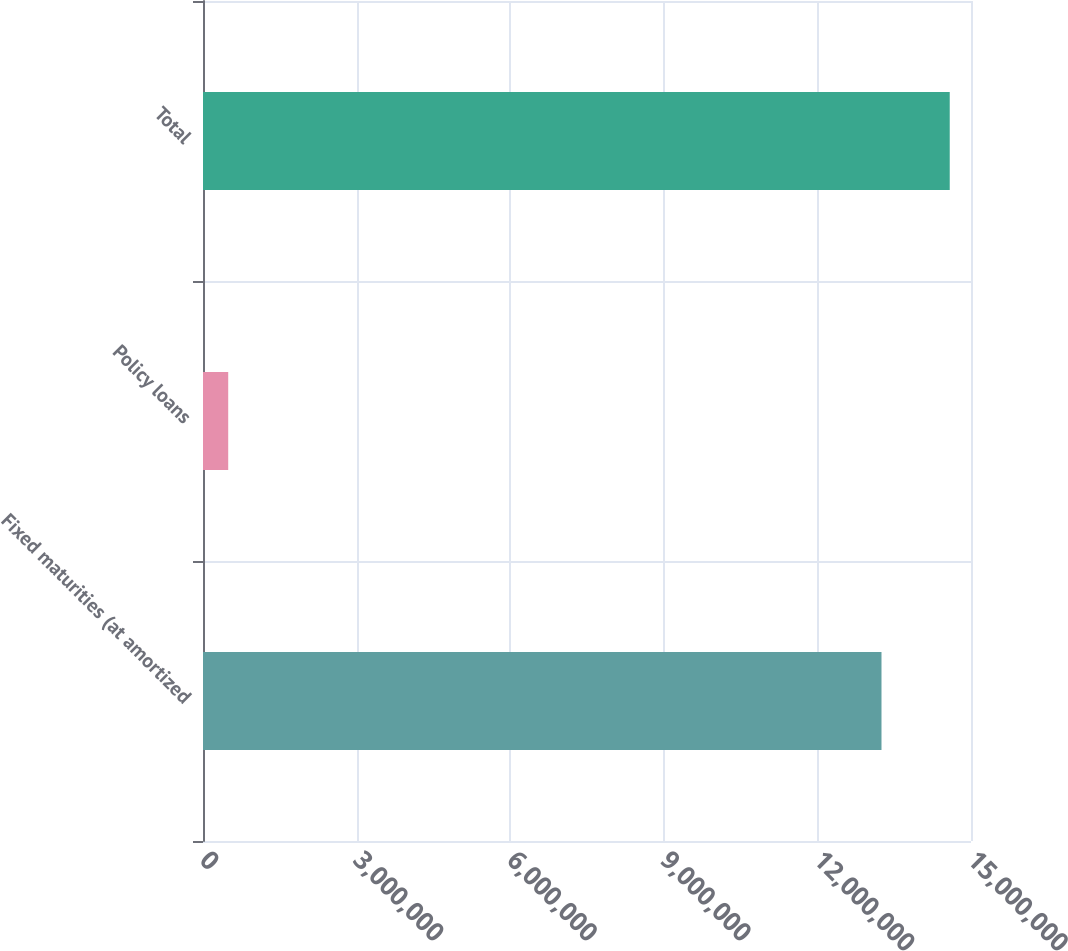<chart> <loc_0><loc_0><loc_500><loc_500><bar_chart><fcel>Fixed maturities (at amortized<fcel>Policy loans<fcel>Total<nl><fcel>1.32519e+07<fcel>492462<fcel>1.45847e+07<nl></chart> 